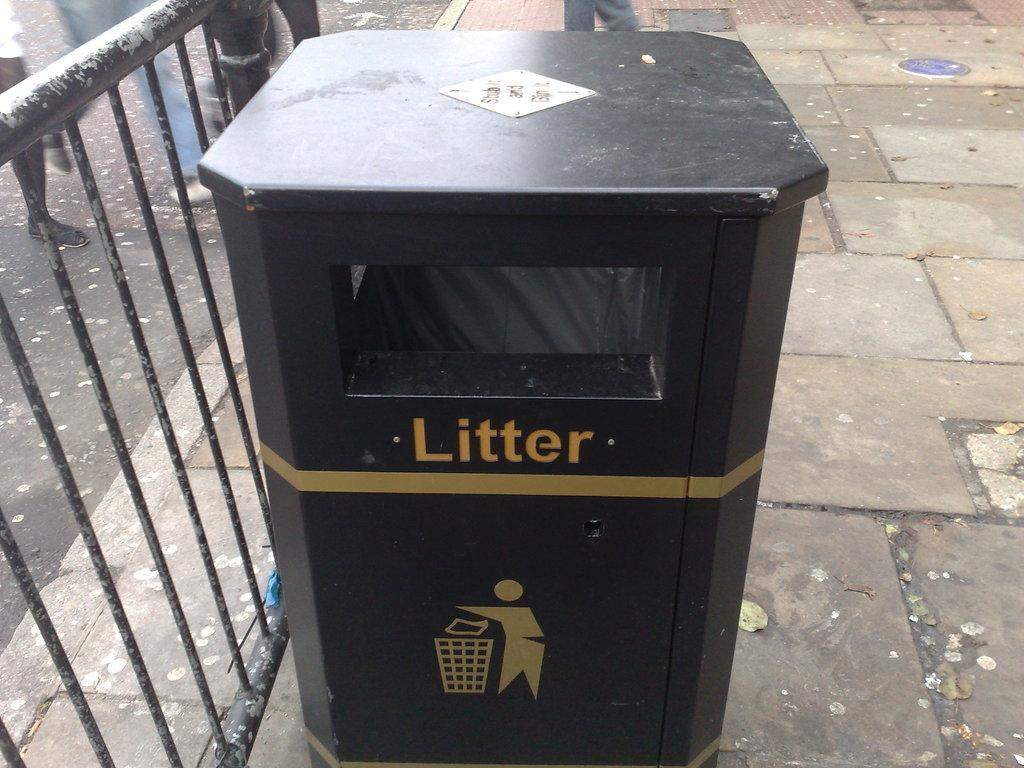<image>
Write a terse but informative summary of the picture. A bin labeled "litter" sits next to an iron fence. 